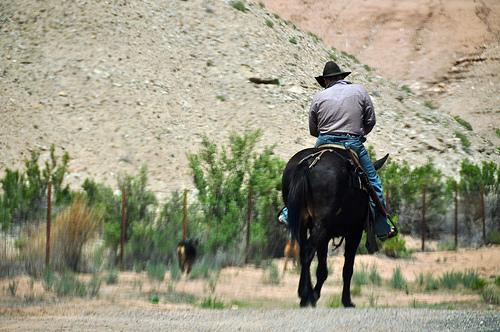Identify the primary means of transportation in the image. Horseback riding is the primary means of transportation in the image. List two objects present on the ground in the image. Small grey stone pebbles and gravel. Identify the main activity taking place in the image and the primary subject involved. Man horseback riding is the main activity, and the primary subject is a man on a black horse. Describe the terrain or landscape features present in the image. The terrain features a hill with dirt surface, patches of grass, and small trees scattered around. Are there any animals present in the image? If so, what are they doing? Yes, a black horse with a man riding it and a small black calf near the fence. Provide a concise description of the main character in the image and his appearance. A man wearing a cowboy hat, grey shirt, and blue jeans is riding a black horse. Describe the general environment of the image. The image features an outdoor environment with a hill, scattered trees, and a fence. What type of hat is the man wearing and what color is it? The man is wearing an old black cowboy hat. Enumerate two pieces of clothing the man is wearing in the image. The man is wearing a grey shirt and blue jeans. What is the most prominent color in the image and which object it is related to? Black is the most prominent color, related to the man's horse and cowboy hat. 